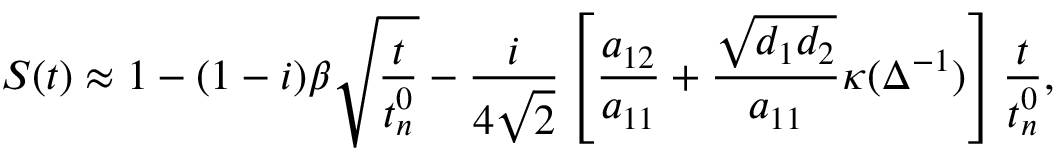<formula> <loc_0><loc_0><loc_500><loc_500>S ( t ) \approx 1 - ( 1 - i ) \beta \sqrt { \frac { t } { t _ { n } ^ { 0 } } } - \frac { i } { 4 \sqrt { 2 } } \left [ \frac { a _ { 1 2 } } { a _ { 1 1 } } + \frac { \sqrt { d _ { 1 } d _ { 2 } } } { a _ { 1 1 } } \kappa ( \Delta ^ { - 1 } ) \right ] \frac { t } { t _ { n } ^ { 0 } } ,</formula> 